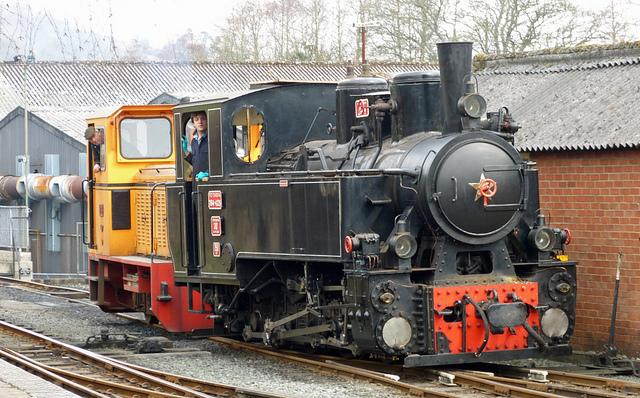Where were the first bricks used? tell assad 